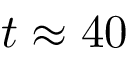<formula> <loc_0><loc_0><loc_500><loc_500>t \approx 4 0</formula> 